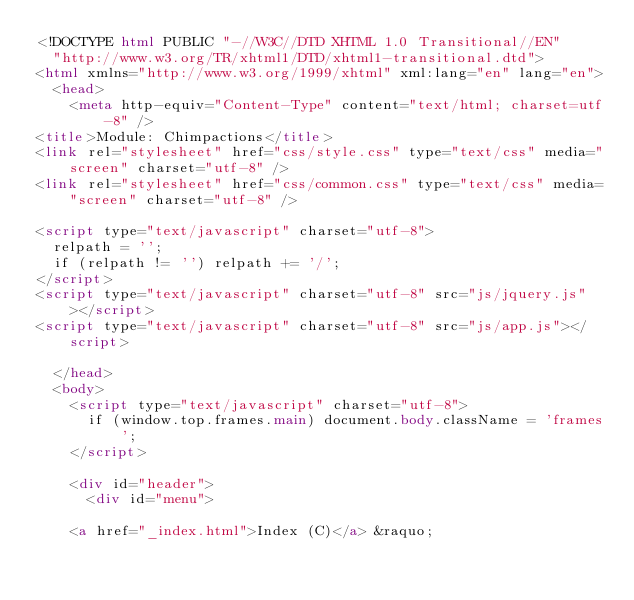Convert code to text. <code><loc_0><loc_0><loc_500><loc_500><_HTML_><!DOCTYPE html PUBLIC "-//W3C//DTD XHTML 1.0 Transitional//EN"
  "http://www.w3.org/TR/xhtml1/DTD/xhtml1-transitional.dtd">
<html xmlns="http://www.w3.org/1999/xhtml" xml:lang="en" lang="en">
  <head>
    <meta http-equiv="Content-Type" content="text/html; charset=utf-8" />
<title>Module: Chimpactions</title>
<link rel="stylesheet" href="css/style.css" type="text/css" media="screen" charset="utf-8" />
<link rel="stylesheet" href="css/common.css" type="text/css" media="screen" charset="utf-8" />

<script type="text/javascript" charset="utf-8">
  relpath = '';
  if (relpath != '') relpath += '/';
</script>
<script type="text/javascript" charset="utf-8" src="js/jquery.js"></script>
<script type="text/javascript" charset="utf-8" src="js/app.js"></script>

  </head>
  <body>
    <script type="text/javascript" charset="utf-8">
      if (window.top.frames.main) document.body.className = 'frames';
    </script>
    
    <div id="header">
      <div id="menu">
  
    <a href="_index.html">Index (C)</a> &raquo; 
    
    </code> 